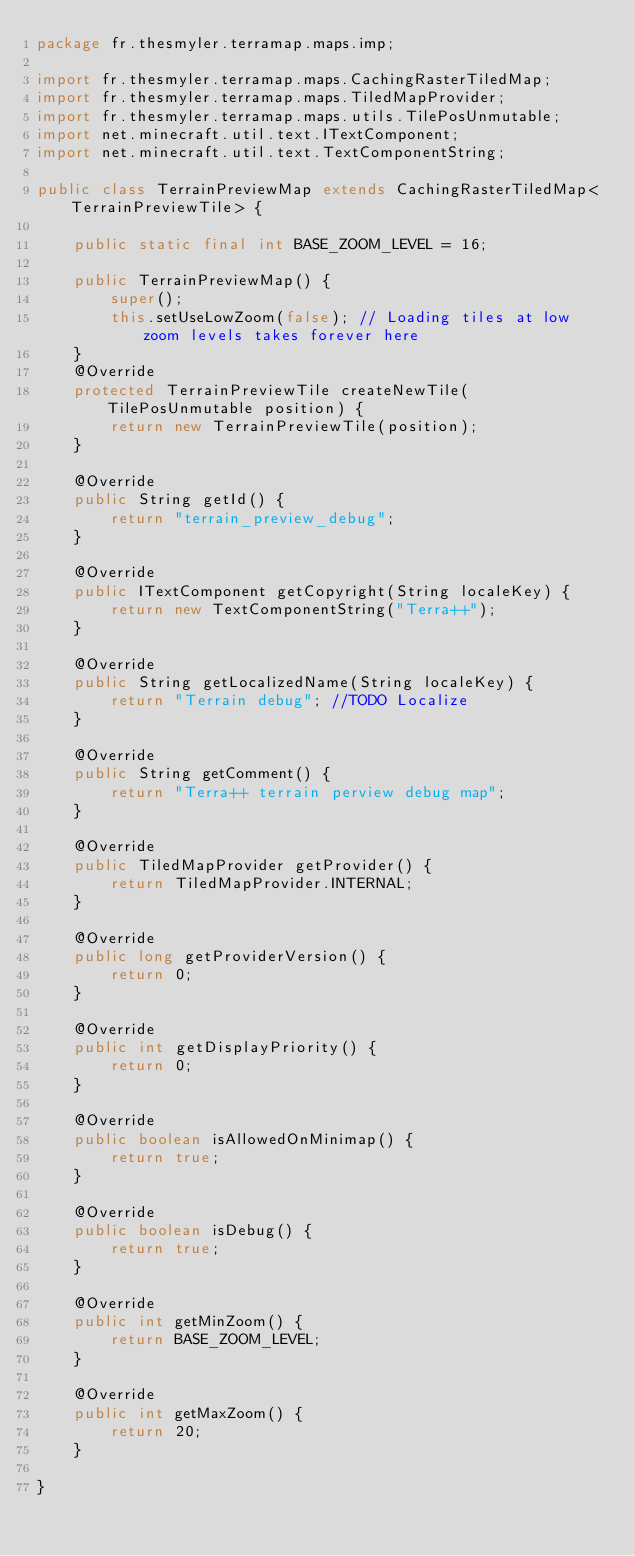<code> <loc_0><loc_0><loc_500><loc_500><_Java_>package fr.thesmyler.terramap.maps.imp;

import fr.thesmyler.terramap.maps.CachingRasterTiledMap;
import fr.thesmyler.terramap.maps.TiledMapProvider;
import fr.thesmyler.terramap.maps.utils.TilePosUnmutable;
import net.minecraft.util.text.ITextComponent;
import net.minecraft.util.text.TextComponentString;

public class TerrainPreviewMap extends CachingRasterTiledMap<TerrainPreviewTile> {
	
	public static final int BASE_ZOOM_LEVEL = 16;

	public TerrainPreviewMap() {
		super();
		this.setUseLowZoom(false); // Loading tiles at low zoom levels takes forever here
	}
	@Override
	protected TerrainPreviewTile createNewTile(TilePosUnmutable position) {
		return new TerrainPreviewTile(position);
	}
	
	@Override
	public String getId() {
		return "terrain_preview_debug";
	}

	@Override
	public ITextComponent getCopyright(String localeKey) {
		return new TextComponentString("Terra++");
	}

	@Override
	public String getLocalizedName(String localeKey) {
		return "Terrain debug"; //TODO Localize
	}

	@Override
	public String getComment() {
		return "Terra++ terrain perview debug map";
	}

	@Override
	public TiledMapProvider getProvider() {
		return TiledMapProvider.INTERNAL;
	}

	@Override
	public long getProviderVersion() {
		return 0;
	}

	@Override
	public int getDisplayPriority() {
		return 0;
	}

	@Override
	public boolean isAllowedOnMinimap() {
		return true;
	}

	@Override
	public boolean isDebug() {
		return true;
	}

	@Override
	public int getMinZoom() {
		return BASE_ZOOM_LEVEL;
	}
	
	@Override
	public int getMaxZoom() {
		return 20;
	}

}
</code> 